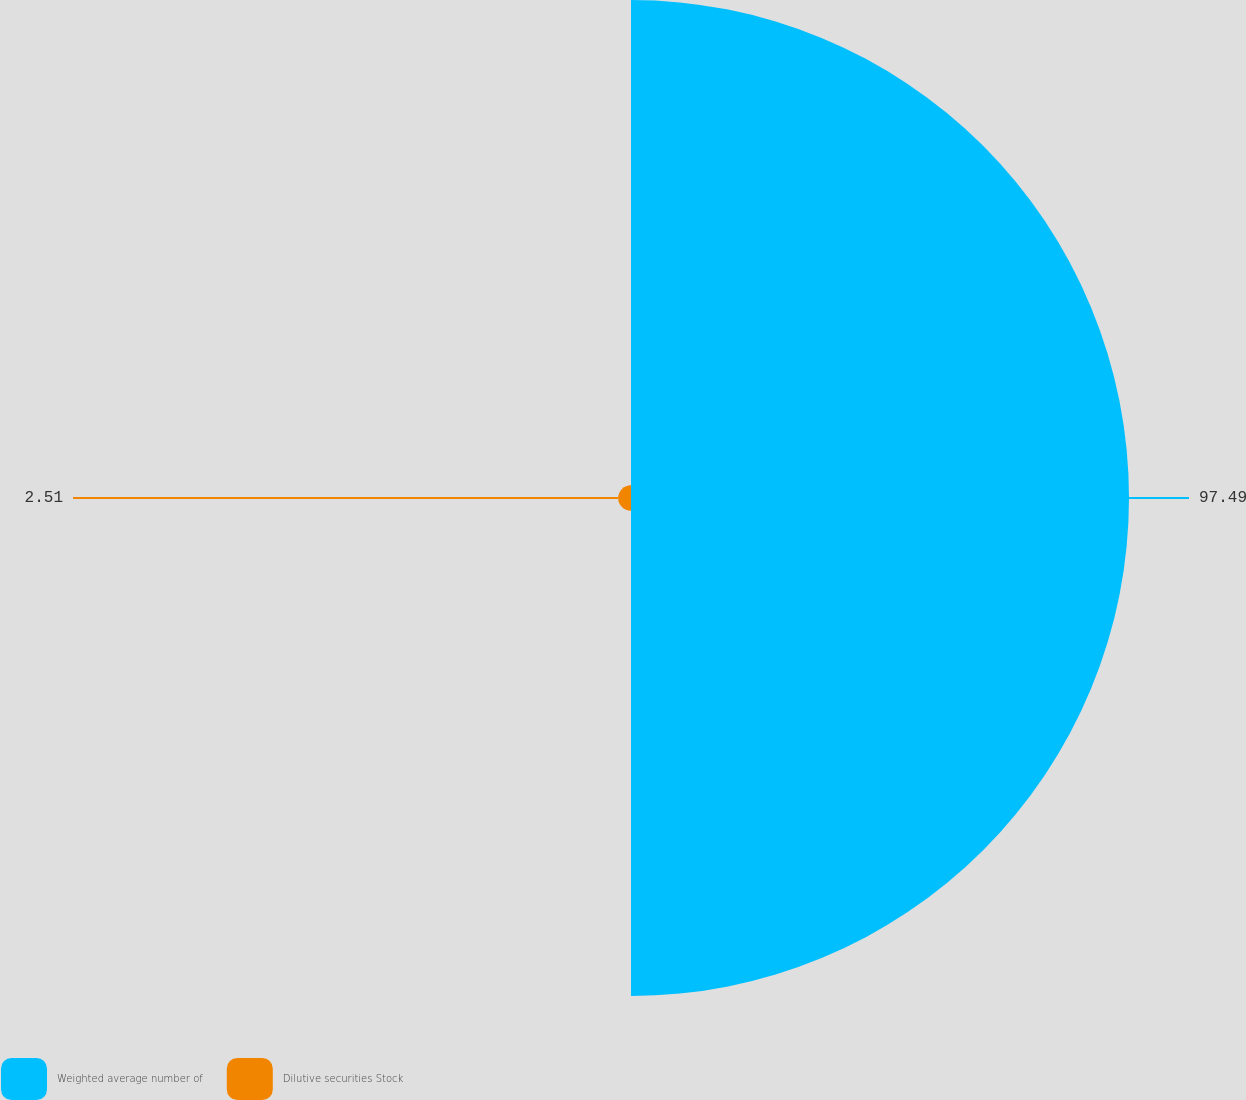Convert chart to OTSL. <chart><loc_0><loc_0><loc_500><loc_500><pie_chart><fcel>Weighted average number of<fcel>Dilutive securities Stock<nl><fcel>97.49%<fcel>2.51%<nl></chart> 